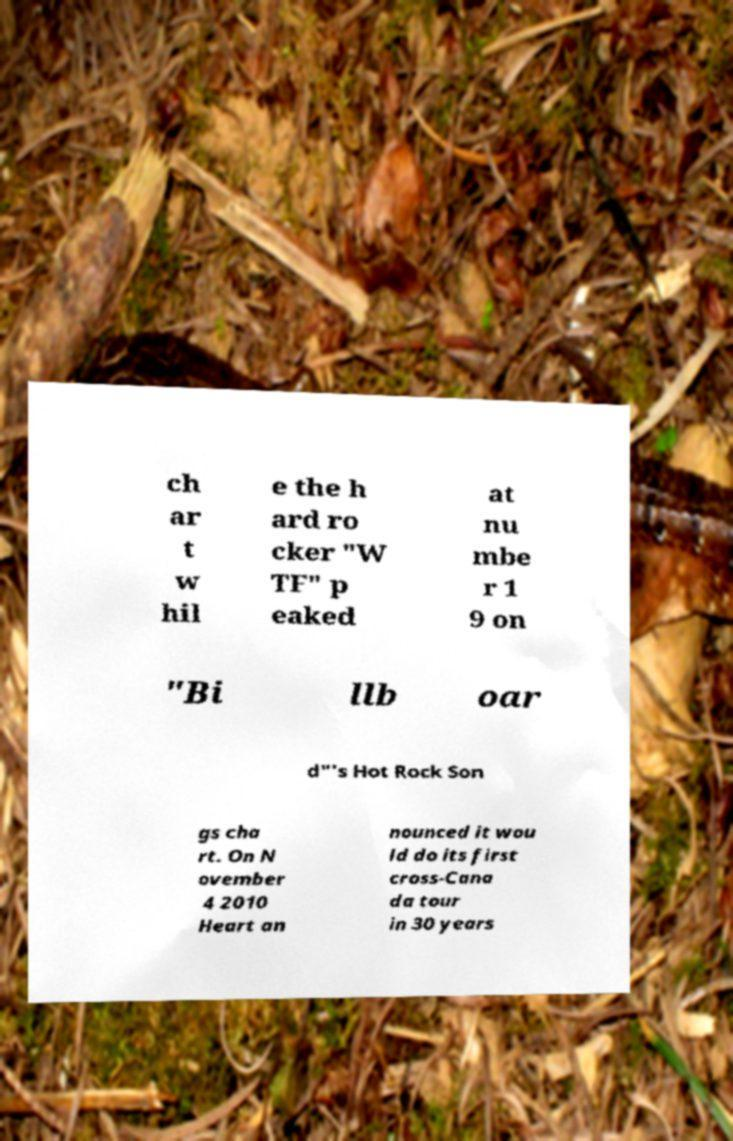Can you accurately transcribe the text from the provided image for me? ch ar t w hil e the h ard ro cker "W TF" p eaked at nu mbe r 1 9 on "Bi llb oar d"'s Hot Rock Son gs cha rt. On N ovember 4 2010 Heart an nounced it wou ld do its first cross-Cana da tour in 30 years 